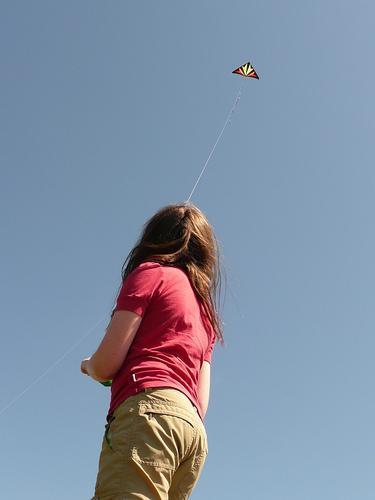How many people are in this photo?
Give a very brief answer. 1. 